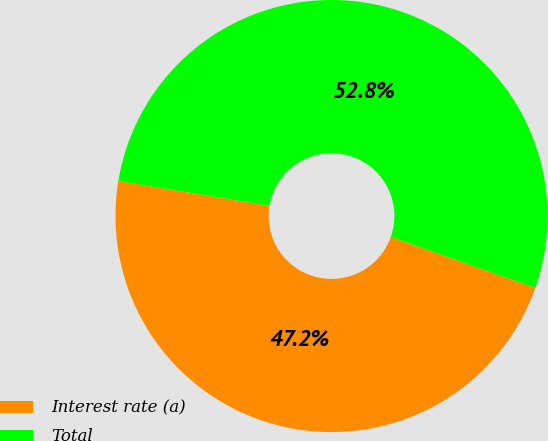<chart> <loc_0><loc_0><loc_500><loc_500><pie_chart><fcel>Interest rate (a)<fcel>Total<nl><fcel>47.19%<fcel>52.81%<nl></chart> 